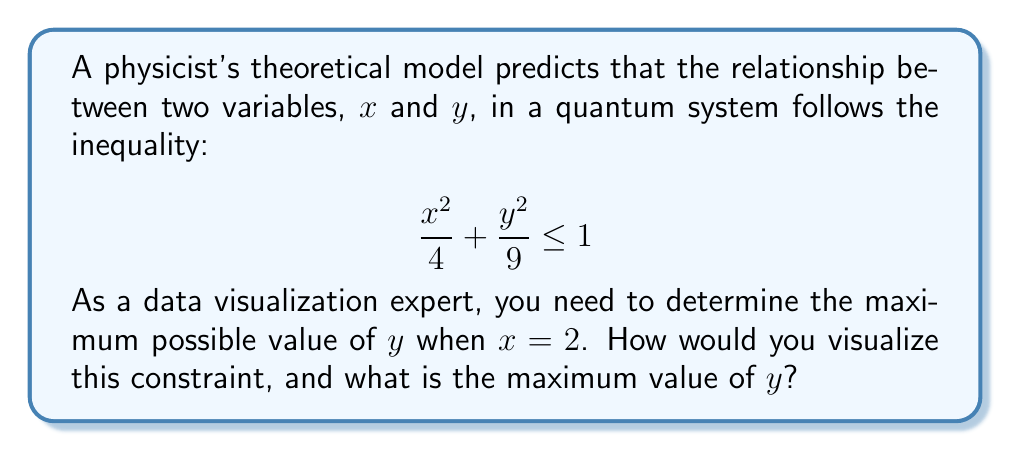Help me with this question. 1. First, let's understand the inequality:
   $$ \frac{x^2}{4} + \frac{y^2}{9} \leq 1 $$
   This is the equation of an ellipse centered at the origin.

2. We're given that x = 2. Let's substitute this into the inequality:
   $$ \frac{2^2}{4} + \frac{y^2}{9} \leq 1 $$

3. Simplify:
   $$ 1 + \frac{y^2}{9} \leq 1 $$

4. Subtract 1 from both sides:
   $$ \frac{y^2}{9} \leq 0 $$

5. Multiply both sides by 9:
   $$ y^2 \leq 0 $$

6. Take the square root of both sides:
   $$ -0 \leq y \leq 0 $$

7. Therefore, the maximum value of y when x = 2 is 0.

To visualize this:

[asy]
import graph;
size(200);
xaxis("x", -3, 3, Arrow);
yaxis("y", -3, 3, Arrow);
draw(ellipse((0,0), 2, 3), blue);
dot((2,0), red);
label("(2,0)", (2,0), E);
[/asy]

This graph shows the ellipse defined by the inequality. The red dot represents the point (2,0), which is the maximum y value when x = 2.
Answer: 0 